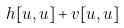Convert formula to latex. <formula><loc_0><loc_0><loc_500><loc_500>h [ u , u ] + v [ u , u ]</formula> 